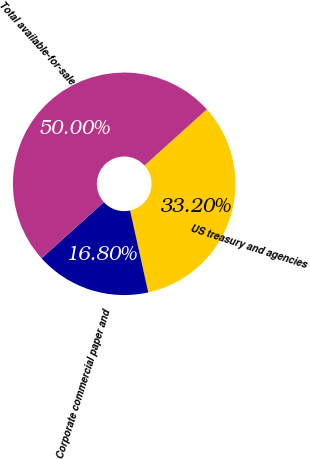Convert chart. <chart><loc_0><loc_0><loc_500><loc_500><pie_chart><fcel>US treasury and agencies<fcel>Corporate commercial paper and<fcel>Total available-for-sale<nl><fcel>33.2%<fcel>16.8%<fcel>50.0%<nl></chart> 